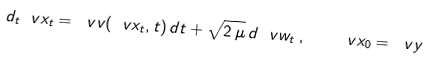Convert formula to latex. <formula><loc_0><loc_0><loc_500><loc_500>d _ { t } \ v x _ { t } = \ v v ( \ v x _ { t } , t ) \, d t + \sqrt { 2 \, \mu } \, d \ v w _ { t } \, , \quad \ v x _ { 0 } = \ v y</formula> 